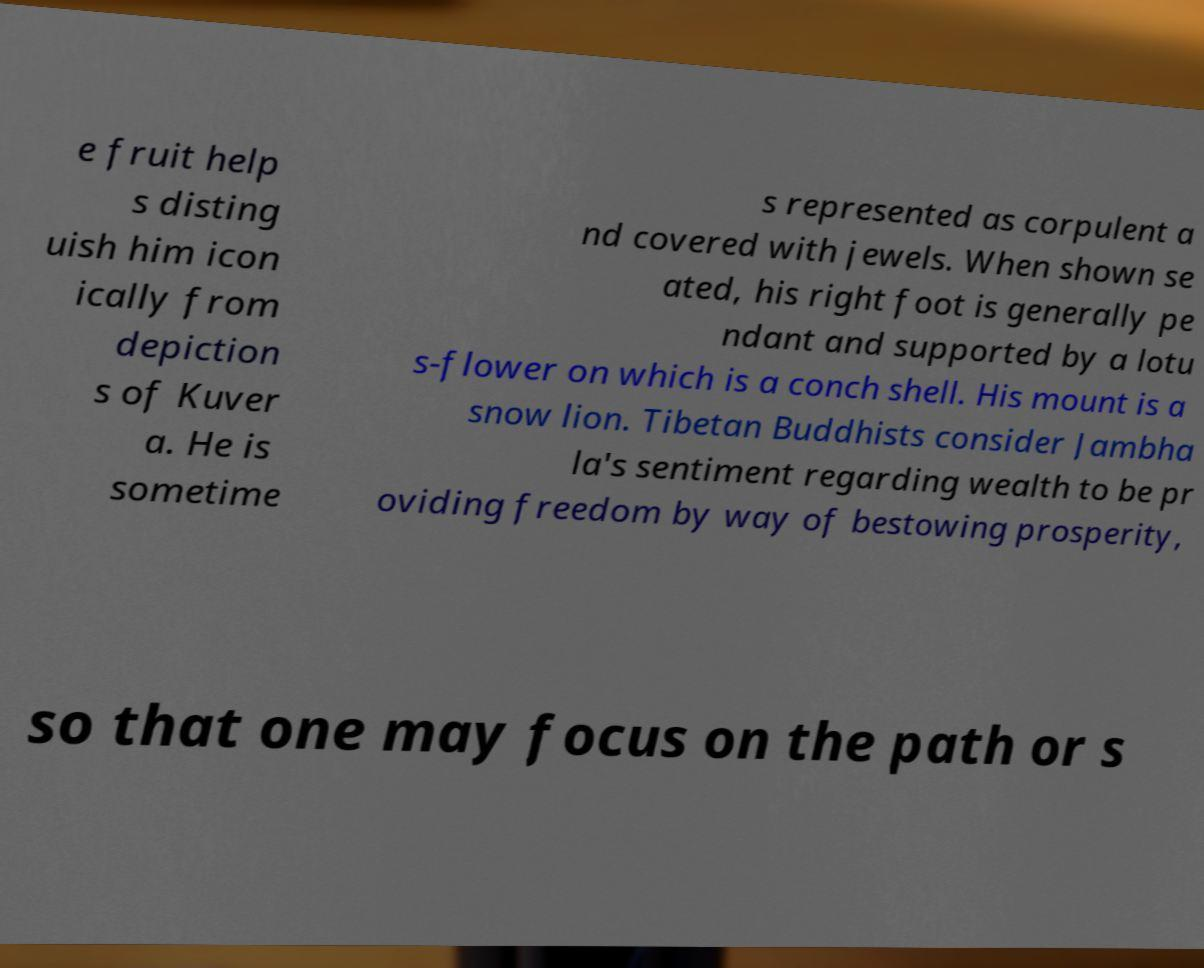Can you read and provide the text displayed in the image?This photo seems to have some interesting text. Can you extract and type it out for me? e fruit help s disting uish him icon ically from depiction s of Kuver a. He is sometime s represented as corpulent a nd covered with jewels. When shown se ated, his right foot is generally pe ndant and supported by a lotu s-flower on which is a conch shell. His mount is a snow lion. Tibetan Buddhists consider Jambha la's sentiment regarding wealth to be pr oviding freedom by way of bestowing prosperity, so that one may focus on the path or s 